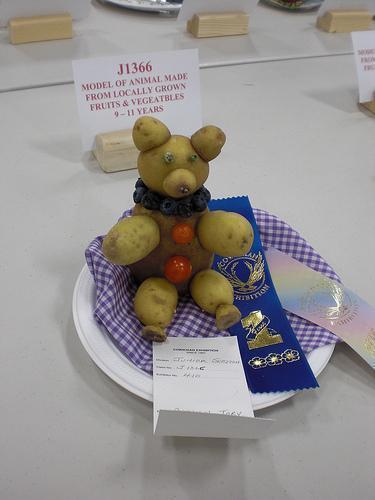How many sculptures are visible?
Give a very brief answer. 1. 